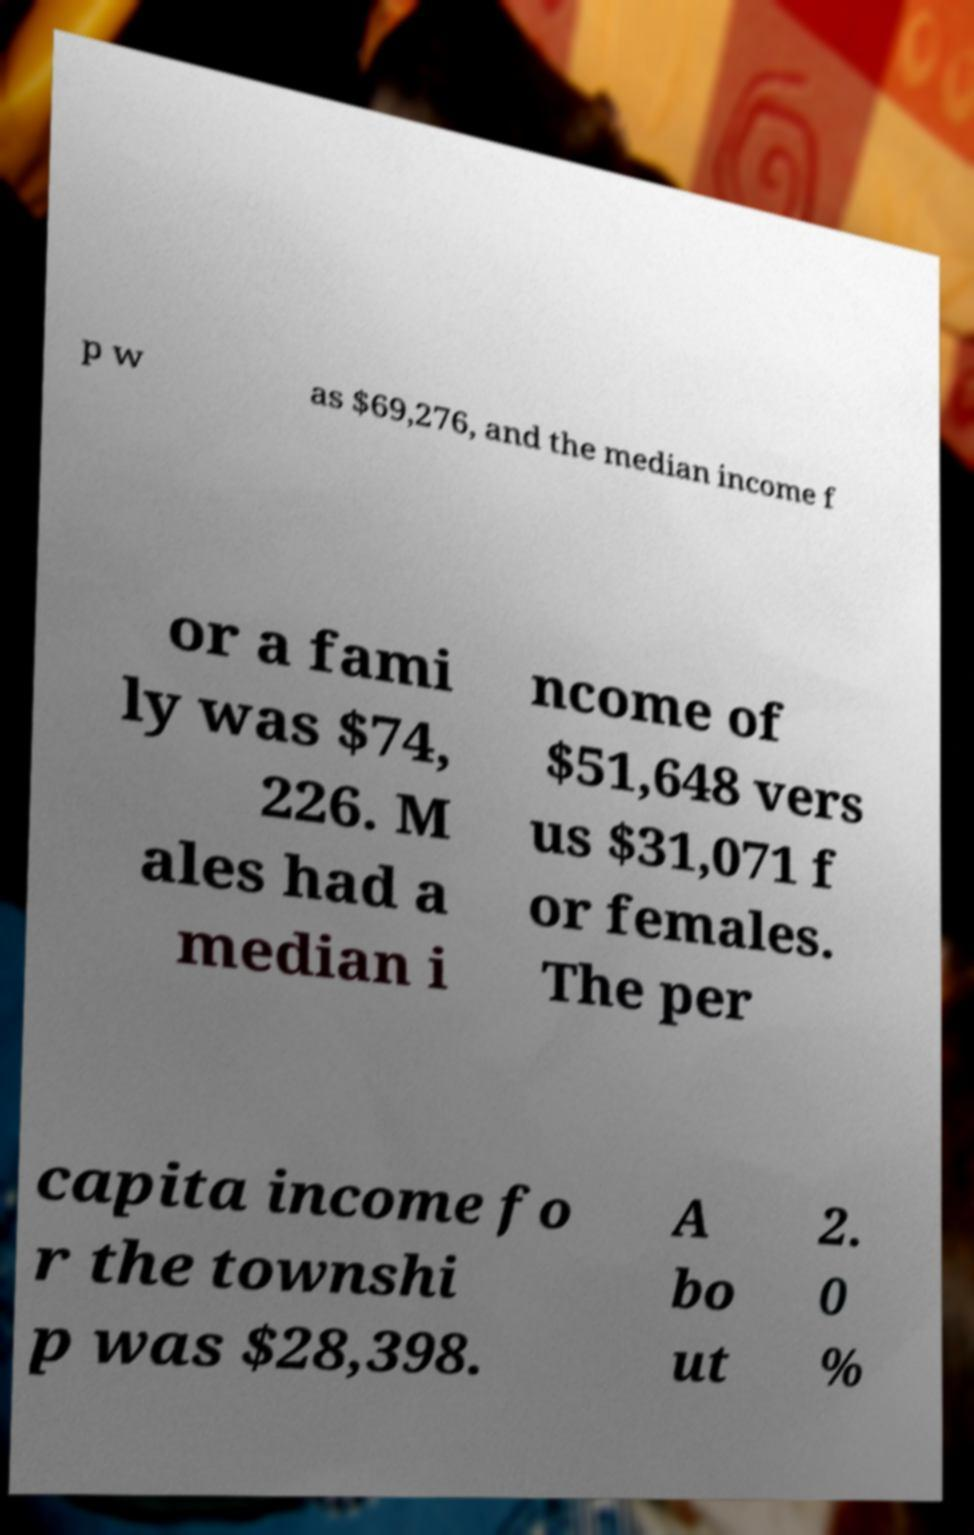Could you extract and type out the text from this image? p w as $69,276, and the median income f or a fami ly was $74, 226. M ales had a median i ncome of $51,648 vers us $31,071 f or females. The per capita income fo r the townshi p was $28,398. A bo ut 2. 0 % 